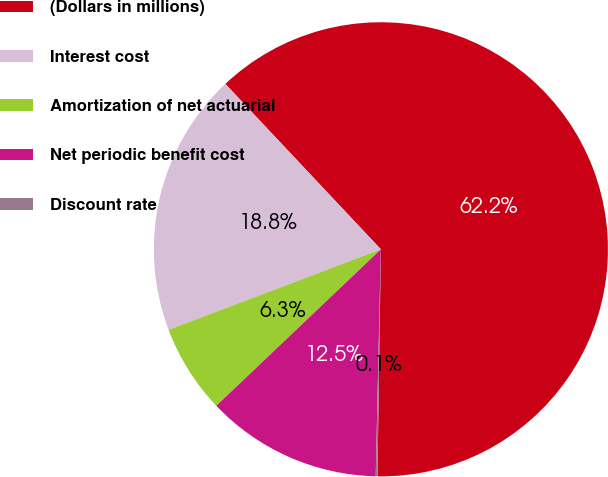Convert chart to OTSL. <chart><loc_0><loc_0><loc_500><loc_500><pie_chart><fcel>(Dollars in millions)<fcel>Interest cost<fcel>Amortization of net actuarial<fcel>Net periodic benefit cost<fcel>Discount rate<nl><fcel>62.25%<fcel>18.76%<fcel>6.33%<fcel>12.54%<fcel>0.12%<nl></chart> 